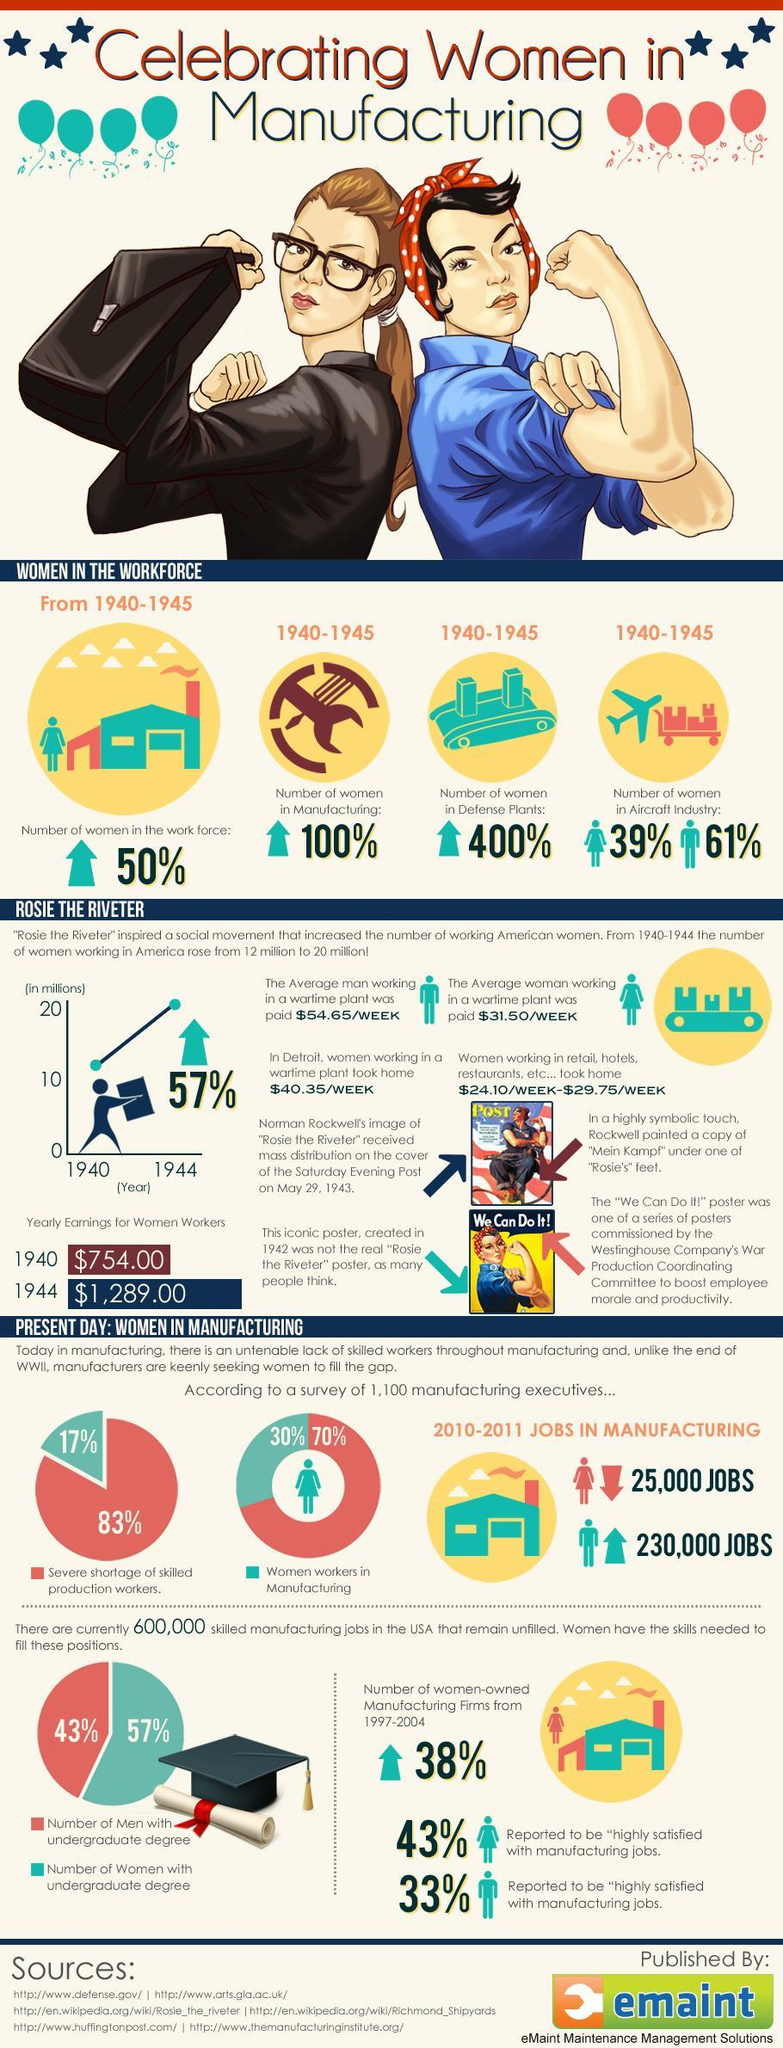During 2010-2011, what percent of women workers were in manufacturing?
Answer the question with a short phrase. 30% What was the percentage of gender gap among those working in aircraft industry during 1940-1945? 22% By how much has yearly earnings for women workers increased from 1940 to 1944? $535.00 According to survey of 1100 manufacturing executives, what percentage faced severe shortage of skilled production workers? 83% During which period did the number of women working in defense plants increase 4 times? 1940-1945 What percent of women had undergraduate degree according to the pie chart? 57% Which gender is majority in aircraft industry -Men or Women? Men What percent of women reported to be highly satisfied with manufacturing jobs? 43% What was the difference in pay between average man and woman working in a wartime plant per week? $23.15 How many sources are listed at the bottom? 6 